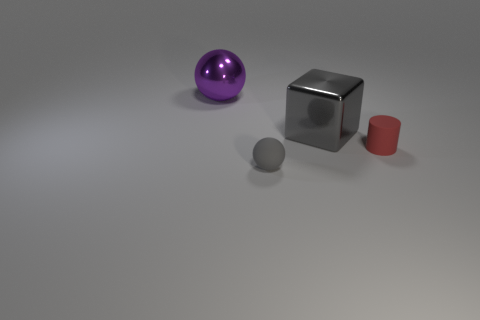There is a ball behind the small sphere; is its color the same as the block?
Your answer should be compact. No. What is the size of the metallic thing on the left side of the tiny object in front of the tiny red cylinder?
Your answer should be very brief. Large. Is the number of large gray metallic cubes that are left of the large purple sphere greater than the number of tiny gray rubber balls?
Offer a very short reply. No. Does the gray thing that is in front of the red thing have the same size as the cylinder?
Your answer should be very brief. Yes. What is the color of the thing that is on the left side of the large gray object and behind the cylinder?
Your answer should be very brief. Purple. The object that is the same size as the purple sphere is what shape?
Your answer should be compact. Cube. Are there any matte things of the same color as the large shiny block?
Your response must be concise. Yes. Are there an equal number of large purple metallic balls that are in front of the tiny matte sphere and big shiny cubes?
Give a very brief answer. No. Is the color of the matte sphere the same as the tiny cylinder?
Give a very brief answer. No. There is a object that is to the left of the large gray metal object and behind the matte cylinder; what is its size?
Offer a very short reply. Large. 